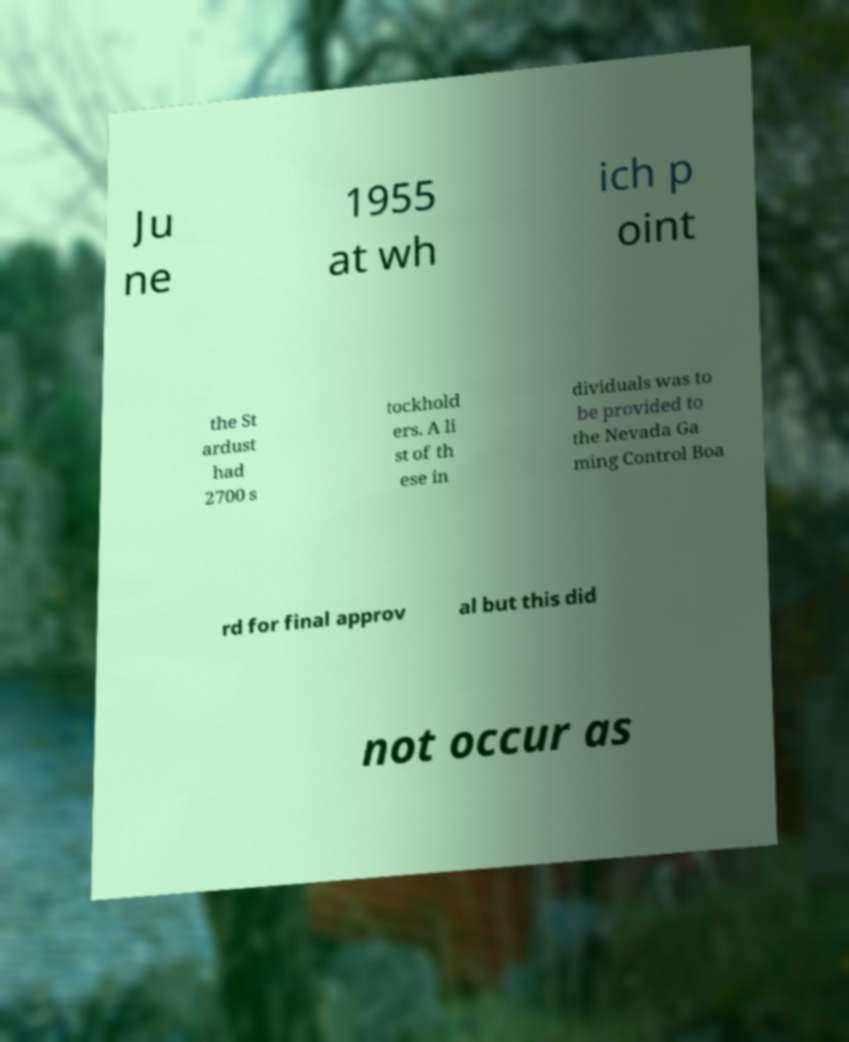Could you assist in decoding the text presented in this image and type it out clearly? Ju ne 1955 at wh ich p oint the St ardust had 2700 s tockhold ers. A li st of th ese in dividuals was to be provided to the Nevada Ga ming Control Boa rd for final approv al but this did not occur as 